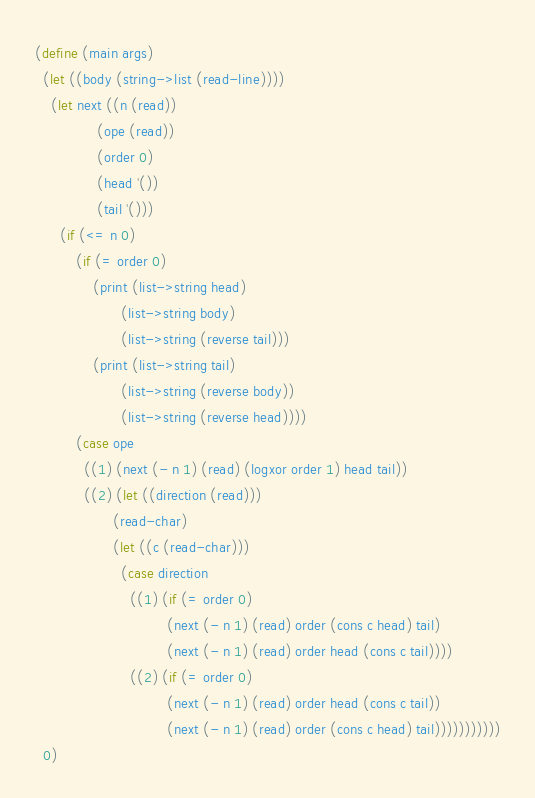<code> <loc_0><loc_0><loc_500><loc_500><_Scheme_>(define (main args)
  (let ((body (string->list (read-line))))
    (let next ((n (read))
               (ope (read))
               (order 0)
               (head '())
               (tail '()))
      (if (<= n 0)
          (if (= order 0)
              (print (list->string head)
                     (list->string body)
                     (list->string (reverse tail)))
              (print (list->string tail)
                     (list->string (reverse body))
                     (list->string (reverse head))))
          (case ope
            ((1) (next (- n 1) (read) (logxor order 1) head tail))
            ((2) (let ((direction (read)))
                   (read-char)
                   (let ((c (read-char)))
                     (case direction
                       ((1) (if (= order 0)
                                (next (- n 1) (read) order (cons c head) tail)
                                (next (- n 1) (read) order head (cons c tail))))
                       ((2) (if (= order 0)
                                (next (- n 1) (read) order head (cons c tail))
                                (next (- n 1) (read) order (cons c head) tail)))))))))))
  0)
</code> 